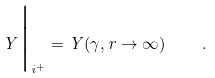Convert formula to latex. <formula><loc_0><loc_0><loc_500><loc_500>Y \Big | _ { i ^ { + } } = Y ( \gamma , r \to \infty ) \quad .</formula> 